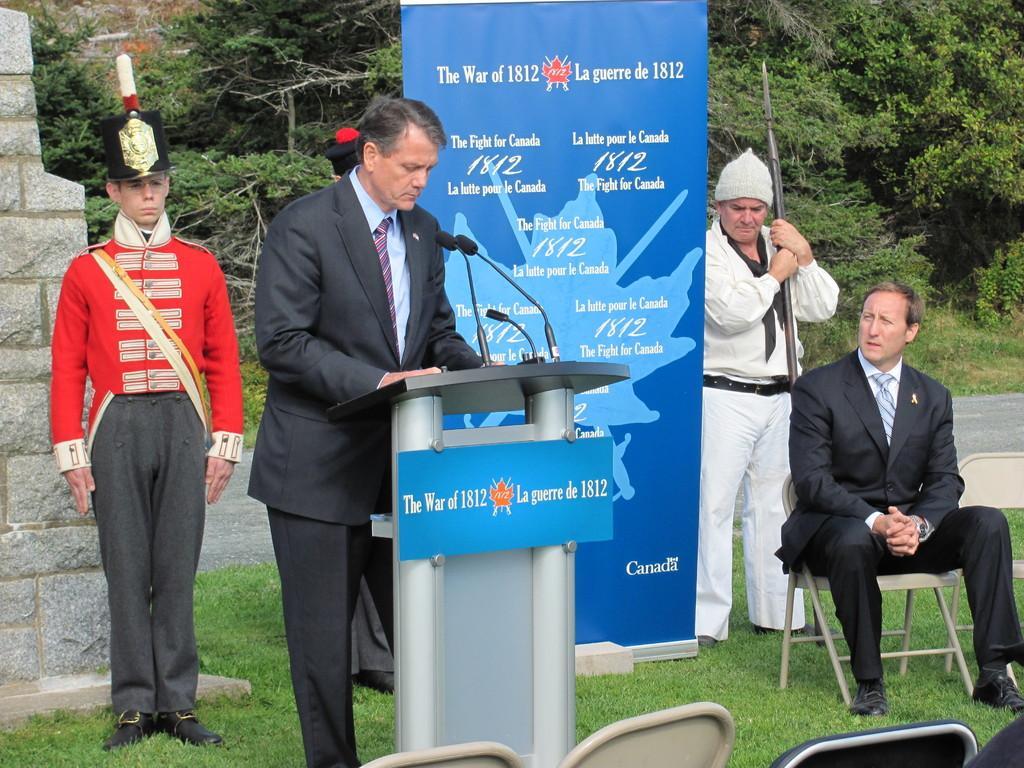In one or two sentences, can you explain what this image depicts? In this image there are people, wall, trees, banner, podium, chairs, mics, board and grass. Among them one person is holding an object and another person is sitting on a chair. In-front of that man there is a podium along with mics and board. Something is written on the banner and board. 